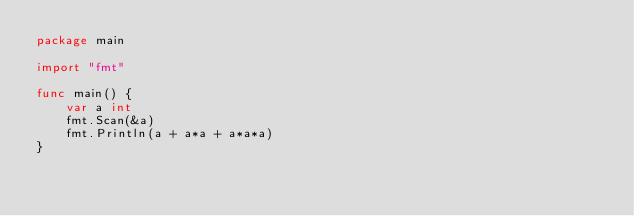<code> <loc_0><loc_0><loc_500><loc_500><_Go_>package main

import "fmt"

func main() {
	var a int
	fmt.Scan(&a)
	fmt.Println(a + a*a + a*a*a)
}
</code> 